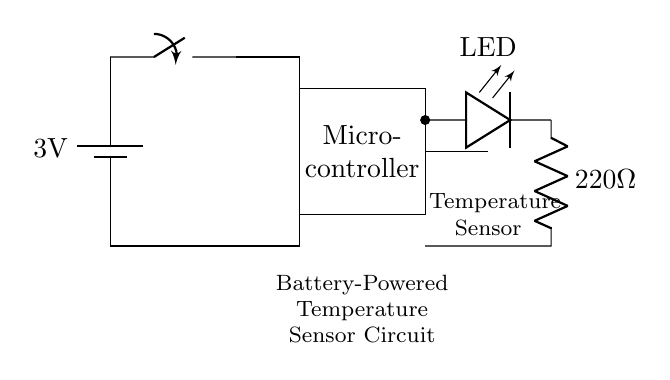What is the voltage of the battery? The circuit shows a battery labeled with a voltage of 3 volts, indicating the potential difference it provides.
Answer: 3 volts What type of sensor is used in this circuit? The diagram features a component specifically labeled as a temperature sensor, which indicates that this circuit is designed for monitoring temperature.
Answer: Temperature sensor What is the purpose of the LED in the circuit? The LED in the circuit acts as an indicator, illuminating to show the status of the circuit, typically whether it is active or indicating a measurement.
Answer: Indicator How many main components are there in this circuit? The circuit comprises a battery, switch, microcontroller, temperature sensor, and LED, making a total of five main components.
Answer: Five What current-limiting component is used with the LED? The circuit includes a resistor, specifically labeled as 220 ohms, which limits the current flowing through the LED to prevent it from burning out.
Answer: 220 ohms What would happen if the temperature sensor fails? If the temperature sensor fails, the microcontroller will not receive any temperature data, leading to a lack of environmental monitoring and potentially incorrect readings or system failure.
Answer: Lack of monitoring What is the primary function of the microcontroller in this circuit? The microcontroller processes the data collected from the temperature sensor for further actions, which may include activating the LED or transmitting data.
Answer: Data processing 